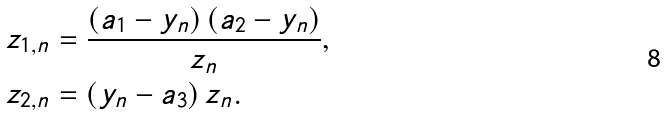<formula> <loc_0><loc_0><loc_500><loc_500>z _ { 1 , n } & = \frac { \left ( a _ { 1 } - y _ { n } \right ) \left ( a _ { 2 } - y _ { n } \right ) } { z _ { n } } , \\ z _ { 2 , n } & = \left ( y _ { n } - a _ { 3 } \right ) z _ { n } .</formula> 